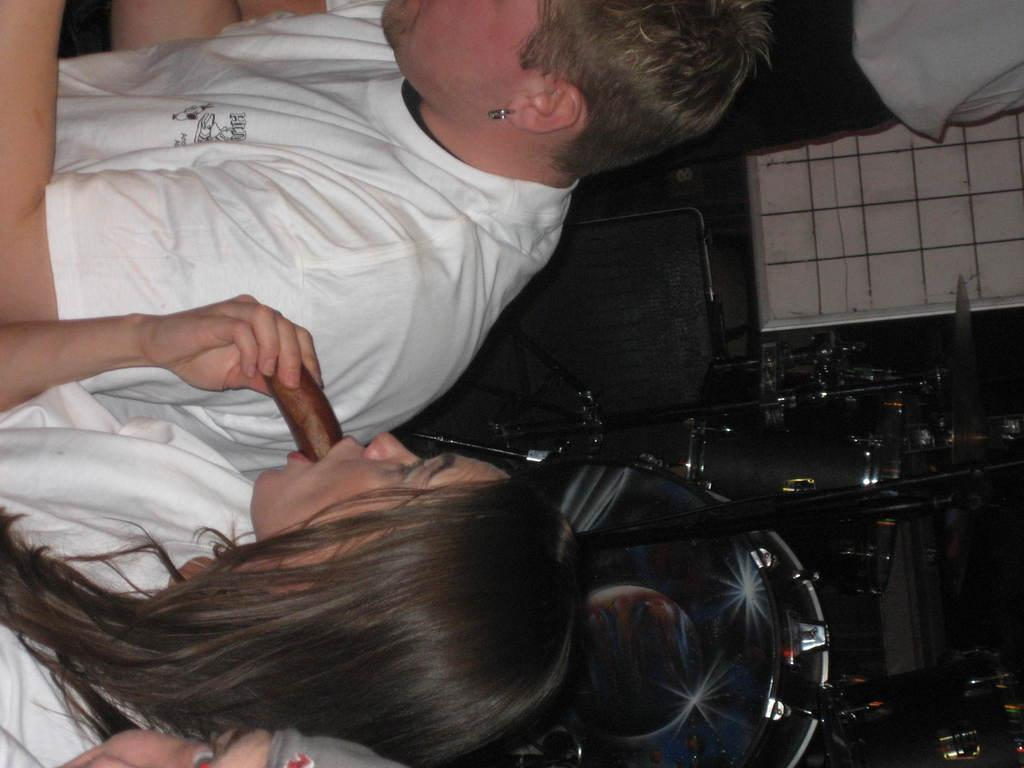How many people are in the image? There are three people in the image. What are the people wearing? The people are wearing white clothes. What can be seen besides the people in the image? There is a food item, earrings, a chair, and other objects in the image. How many hens are present in the image? There are no hens present in the image. What type of kettle can be seen in the image? There is no kettle present in the image. 